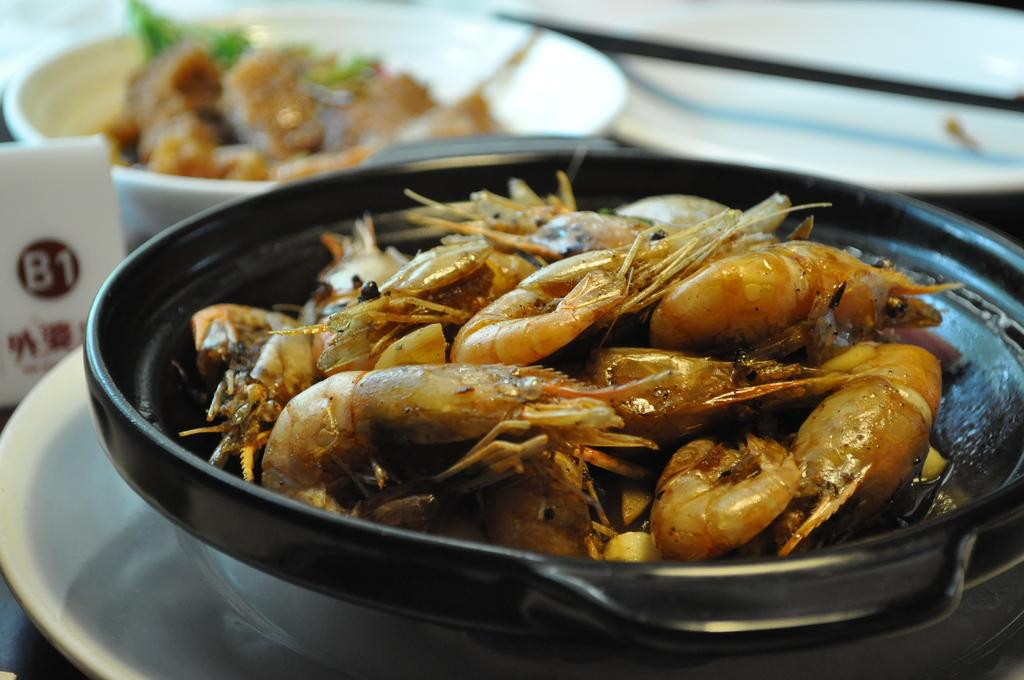What is the main object in the center of the image? There is a plate in the center of the image. What is on the plate? The plate contains cuisine. Where is the bowl located in the image? The bowl is at the top side of the image. What type of tin can be seen on the trail in the image? There is no tin or trail present in the image; it only features a plate with cuisine and a bowl. 